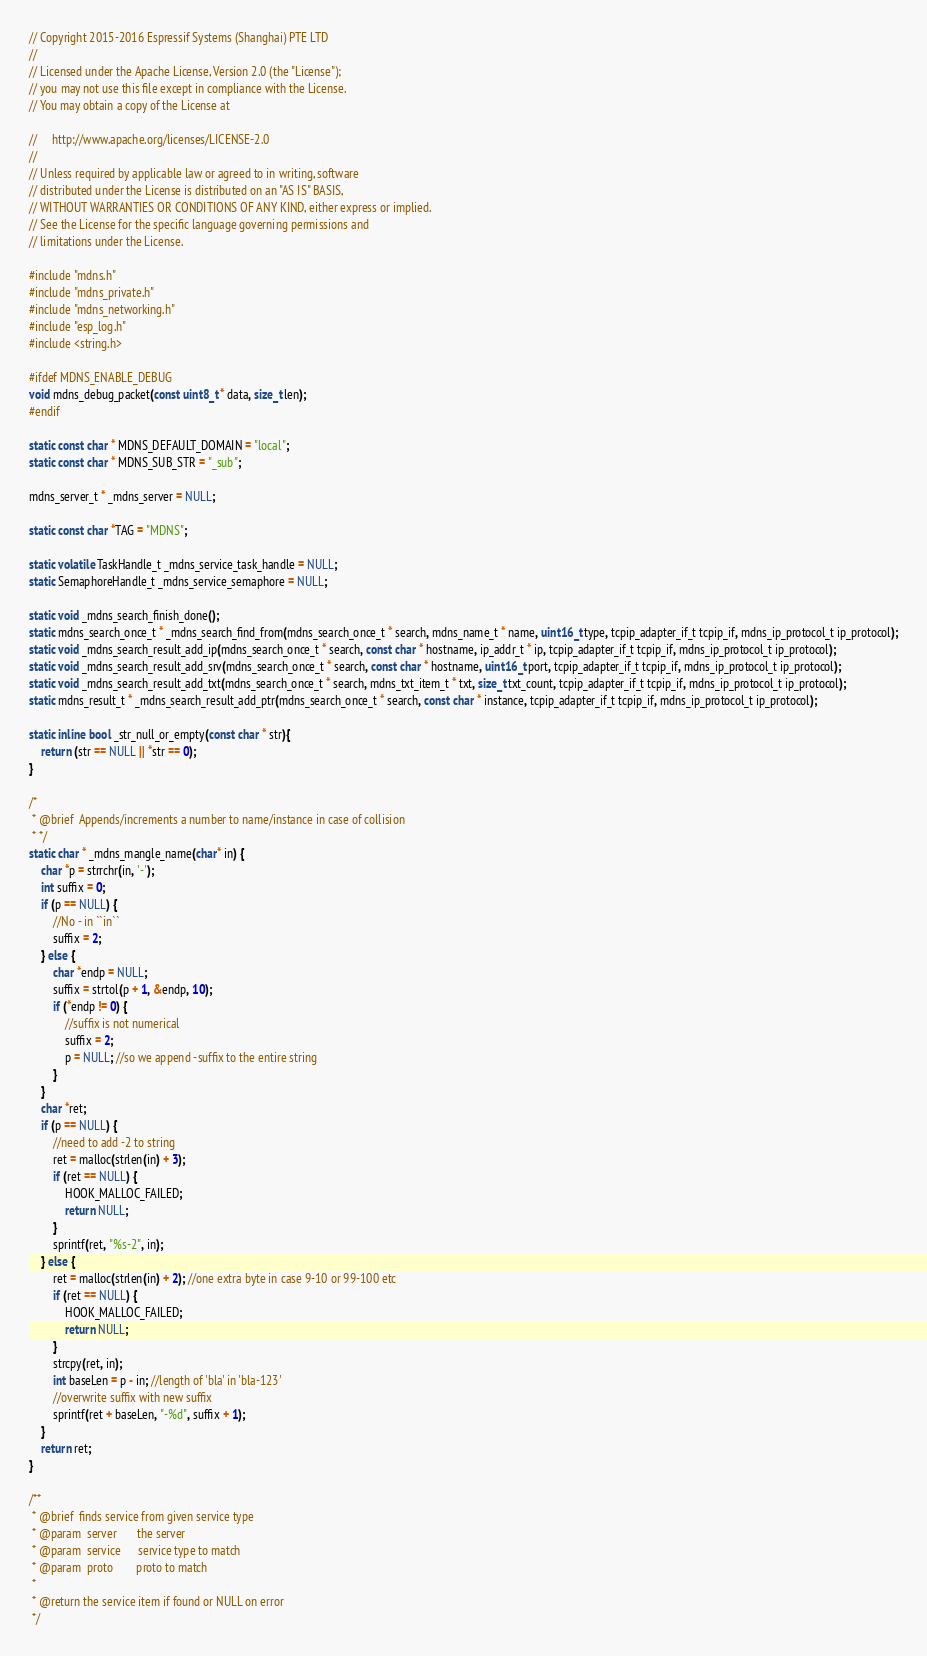<code> <loc_0><loc_0><loc_500><loc_500><_C_>// Copyright 2015-2016 Espressif Systems (Shanghai) PTE LTD
//
// Licensed under the Apache License, Version 2.0 (the "License");
// you may not use this file except in compliance with the License.
// You may obtain a copy of the License at

//     http://www.apache.org/licenses/LICENSE-2.0
//
// Unless required by applicable law or agreed to in writing, software
// distributed under the License is distributed on an "AS IS" BASIS,
// WITHOUT WARRANTIES OR CONDITIONS OF ANY KIND, either express or implied.
// See the License for the specific language governing permissions and
// limitations under the License.

#include "mdns.h"
#include "mdns_private.h"
#include "mdns_networking.h"
#include "esp_log.h"
#include <string.h>

#ifdef MDNS_ENABLE_DEBUG
void mdns_debug_packet(const uint8_t * data, size_t len);
#endif

static const char * MDNS_DEFAULT_DOMAIN = "local";
static const char * MDNS_SUB_STR = "_sub";

mdns_server_t * _mdns_server = NULL;

static const char *TAG = "MDNS";

static volatile TaskHandle_t _mdns_service_task_handle = NULL;
static SemaphoreHandle_t _mdns_service_semaphore = NULL;

static void _mdns_search_finish_done();
static mdns_search_once_t * _mdns_search_find_from(mdns_search_once_t * search, mdns_name_t * name, uint16_t type, tcpip_adapter_if_t tcpip_if, mdns_ip_protocol_t ip_protocol);
static void _mdns_search_result_add_ip(mdns_search_once_t * search, const char * hostname, ip_addr_t * ip, tcpip_adapter_if_t tcpip_if, mdns_ip_protocol_t ip_protocol);
static void _mdns_search_result_add_srv(mdns_search_once_t * search, const char * hostname, uint16_t port, tcpip_adapter_if_t tcpip_if, mdns_ip_protocol_t ip_protocol);
static void _mdns_search_result_add_txt(mdns_search_once_t * search, mdns_txt_item_t * txt, size_t txt_count, tcpip_adapter_if_t tcpip_if, mdns_ip_protocol_t ip_protocol);
static mdns_result_t * _mdns_search_result_add_ptr(mdns_search_once_t * search, const char * instance, tcpip_adapter_if_t tcpip_if, mdns_ip_protocol_t ip_protocol);

static inline bool _str_null_or_empty(const char * str){
    return (str == NULL || *str == 0);
}

/*
 * @brief  Appends/increments a number to name/instance in case of collision
 * */
static char * _mdns_mangle_name(char* in) {
    char *p = strrchr(in, '-');
    int suffix = 0;
    if (p == NULL) {
        //No - in ``in``
        suffix = 2;
    } else {
        char *endp = NULL;
        suffix = strtol(p + 1, &endp, 10);
        if (*endp != 0) {
            //suffix is not numerical
            suffix = 2;
            p = NULL; //so we append -suffix to the entire string
        }
    }
    char *ret;
    if (p == NULL) {
        //need to add -2 to string
        ret = malloc(strlen(in) + 3);
        if (ret == NULL) {
            HOOK_MALLOC_FAILED;
            return NULL;
        }
        sprintf(ret, "%s-2", in);
    } else {
        ret = malloc(strlen(in) + 2); //one extra byte in case 9-10 or 99-100 etc
        if (ret == NULL) {
            HOOK_MALLOC_FAILED;
            return NULL;
        }
        strcpy(ret, in);
        int baseLen = p - in; //length of 'bla' in 'bla-123'
        //overwrite suffix with new suffix
        sprintf(ret + baseLen, "-%d", suffix + 1);
    }
    return ret;
}

/**
 * @brief  finds service from given service type
 * @param  server       the server
 * @param  service      service type to match
 * @param  proto        proto to match
 *
 * @return the service item if found or NULL on error
 */</code> 